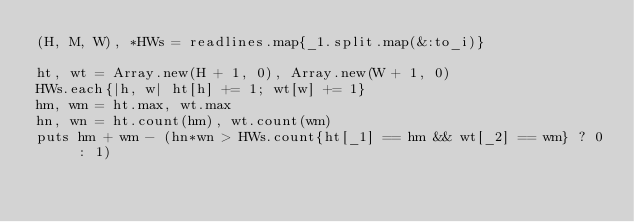<code> <loc_0><loc_0><loc_500><loc_500><_Ruby_>(H, M, W), *HWs = readlines.map{_1.split.map(&:to_i)}

ht, wt = Array.new(H + 1, 0), Array.new(W + 1, 0)
HWs.each{|h, w| ht[h] += 1; wt[w] += 1}
hm, wm = ht.max, wt.max
hn, wn = ht.count(hm), wt.count(wm)
puts hm + wm - (hn*wn > HWs.count{ht[_1] == hm && wt[_2] == wm} ? 0 : 1)</code> 